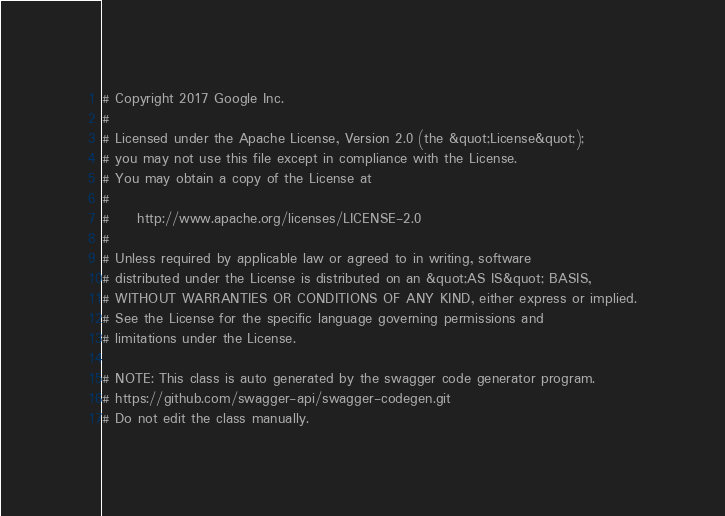<code> <loc_0><loc_0><loc_500><loc_500><_Elixir_># Copyright 2017 Google Inc.
#
# Licensed under the Apache License, Version 2.0 (the &quot;License&quot;);
# you may not use this file except in compliance with the License.
# You may obtain a copy of the License at
#
#     http://www.apache.org/licenses/LICENSE-2.0
#
# Unless required by applicable law or agreed to in writing, software
# distributed under the License is distributed on an &quot;AS IS&quot; BASIS,
# WITHOUT WARRANTIES OR CONDITIONS OF ANY KIND, either express or implied.
# See the License for the specific language governing permissions and
# limitations under the License.

# NOTE: This class is auto generated by the swagger code generator program.
# https://github.com/swagger-api/swagger-codegen.git
# Do not edit the class manually.
</code> 